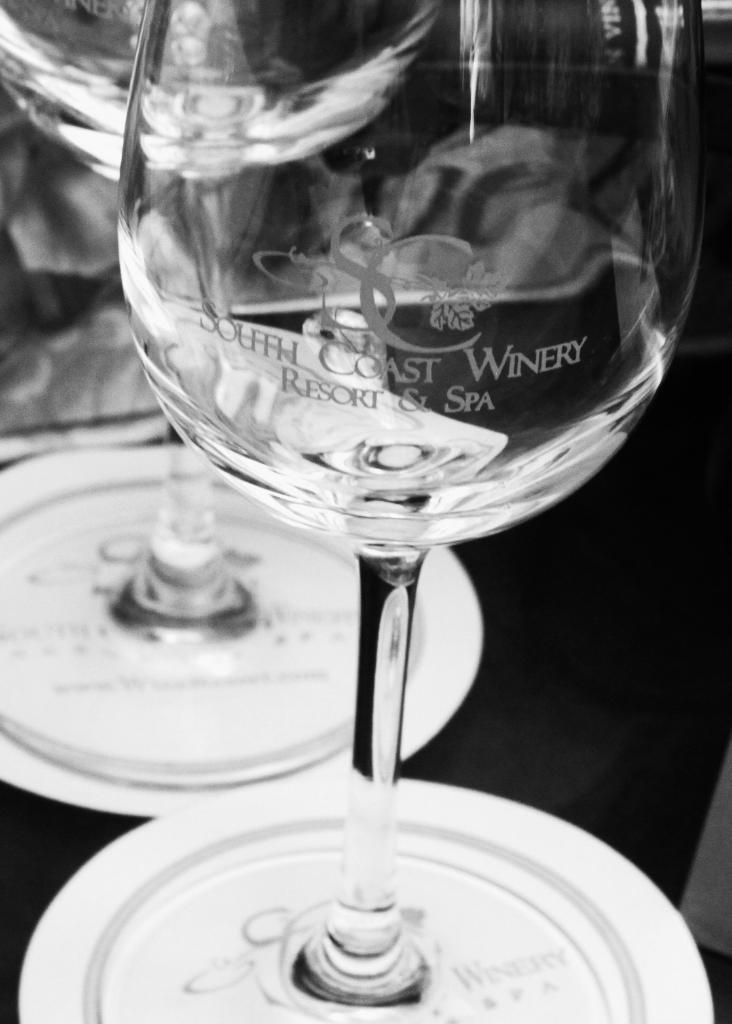What objects are on the table in the image? There are glasses on the table in the image. What is the color scheme of the image? The image is in black and white. What type of meat is being served on the table in the image? There is no meat present in the image; it only shows glasses on a table. What type of cloth is draped over the table in the image? There is no cloth draped over the table in the image; it only shows glasses on a table. 